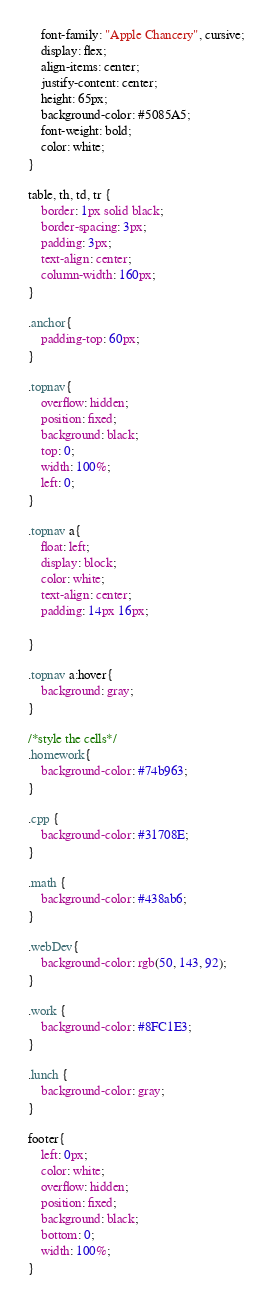Convert code to text. <code><loc_0><loc_0><loc_500><loc_500><_CSS_>    font-family: "Apple Chancery", cursive;
    display: flex;
    align-items: center;
    justify-content: center;
    height: 65px;
    background-color: #5085A5;
    font-weight: bold;
    color: white;
}

table, th, td, tr {
    border: 1px solid black;
    border-spacing: 3px;
    padding: 3px;
    text-align: center;
    column-width: 160px;
}

.anchor{
    padding-top: 60px;
}

.topnav{
    overflow: hidden;
    position: fixed;
    background: black;
    top: 0;
    width: 100%;
    left: 0;
}

.topnav a{
    float: left;
    display: block;
    color: white;
    text-align: center;
    padding: 14px 16px;

}

.topnav a:hover{
    background: gray;
}

/*style the cells*/
.homework{
    background-color: #74b963;
}

.cpp {
    background-color: #31708E;
}

.math {
    background-color: #438ab6;
}

.webDev{
    background-color: rgb(50, 143, 92);
}

.work {
    background-color: #8FC1E3;
}

.lunch {
    background-color: gray;
}

footer{
    left: 0px;
    color: white;
    overflow: hidden;
    position: fixed;
    background: black;
    bottom: 0;
    width: 100%;
}
</code> 